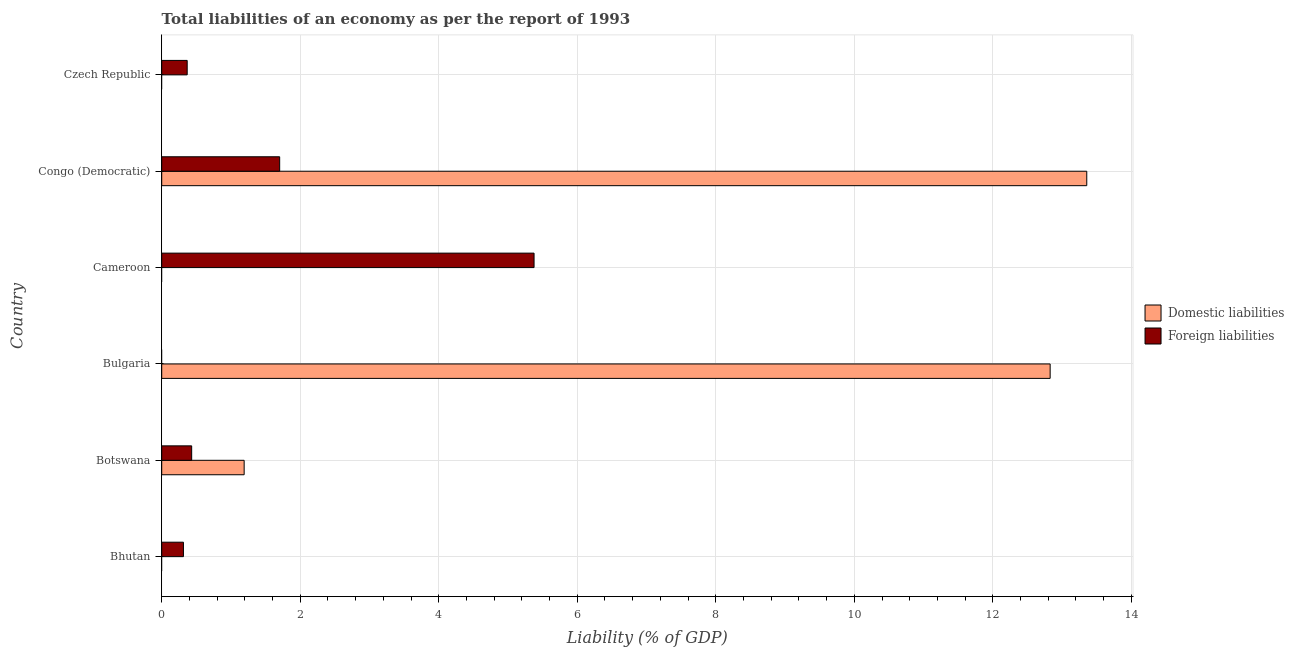How many different coloured bars are there?
Provide a succinct answer. 2. Are the number of bars on each tick of the Y-axis equal?
Provide a succinct answer. No. What is the incurrence of foreign liabilities in Botswana?
Offer a terse response. 0.43. Across all countries, what is the maximum incurrence of foreign liabilities?
Give a very brief answer. 5.38. Across all countries, what is the minimum incurrence of domestic liabilities?
Your answer should be very brief. 0. In which country was the incurrence of foreign liabilities maximum?
Your answer should be very brief. Cameroon. What is the total incurrence of foreign liabilities in the graph?
Keep it short and to the point. 8.19. What is the difference between the incurrence of foreign liabilities in Botswana and that in Congo (Democratic)?
Offer a very short reply. -1.27. What is the difference between the incurrence of foreign liabilities in Cameroon and the incurrence of domestic liabilities in Bhutan?
Make the answer very short. 5.38. What is the average incurrence of domestic liabilities per country?
Offer a terse response. 4.56. What is the difference between the incurrence of foreign liabilities and incurrence of domestic liabilities in Congo (Democratic)?
Your response must be concise. -11.65. What is the ratio of the incurrence of foreign liabilities in Botswana to that in Czech Republic?
Keep it short and to the point. 1.18. Is the incurrence of domestic liabilities in Botswana less than that in Bulgaria?
Provide a succinct answer. Yes. What is the difference between the highest and the second highest incurrence of foreign liabilities?
Your answer should be very brief. 3.67. What is the difference between the highest and the lowest incurrence of foreign liabilities?
Provide a short and direct response. 5.38. In how many countries, is the incurrence of domestic liabilities greater than the average incurrence of domestic liabilities taken over all countries?
Offer a terse response. 2. Is the sum of the incurrence of foreign liabilities in Bhutan and Cameroon greater than the maximum incurrence of domestic liabilities across all countries?
Make the answer very short. No. How many bars are there?
Your response must be concise. 8. Are all the bars in the graph horizontal?
Offer a very short reply. Yes. How many countries are there in the graph?
Give a very brief answer. 6. What is the difference between two consecutive major ticks on the X-axis?
Make the answer very short. 2. Does the graph contain any zero values?
Provide a succinct answer. Yes. How are the legend labels stacked?
Your response must be concise. Vertical. What is the title of the graph?
Provide a succinct answer. Total liabilities of an economy as per the report of 1993. Does "Under-5(female)" appear as one of the legend labels in the graph?
Make the answer very short. No. What is the label or title of the X-axis?
Your answer should be very brief. Liability (% of GDP). What is the label or title of the Y-axis?
Your response must be concise. Country. What is the Liability (% of GDP) in Foreign liabilities in Bhutan?
Your response must be concise. 0.31. What is the Liability (% of GDP) of Domestic liabilities in Botswana?
Offer a terse response. 1.19. What is the Liability (% of GDP) in Foreign liabilities in Botswana?
Give a very brief answer. 0.43. What is the Liability (% of GDP) in Domestic liabilities in Bulgaria?
Provide a succinct answer. 12.83. What is the Liability (% of GDP) in Foreign liabilities in Bulgaria?
Give a very brief answer. 0. What is the Liability (% of GDP) in Domestic liabilities in Cameroon?
Provide a short and direct response. 0. What is the Liability (% of GDP) of Foreign liabilities in Cameroon?
Provide a succinct answer. 5.38. What is the Liability (% of GDP) of Domestic liabilities in Congo (Democratic)?
Give a very brief answer. 13.36. What is the Liability (% of GDP) in Foreign liabilities in Congo (Democratic)?
Keep it short and to the point. 1.7. What is the Liability (% of GDP) in Domestic liabilities in Czech Republic?
Give a very brief answer. 0. What is the Liability (% of GDP) in Foreign liabilities in Czech Republic?
Provide a succinct answer. 0.37. Across all countries, what is the maximum Liability (% of GDP) of Domestic liabilities?
Your response must be concise. 13.36. Across all countries, what is the maximum Liability (% of GDP) in Foreign liabilities?
Your answer should be very brief. 5.38. What is the total Liability (% of GDP) in Domestic liabilities in the graph?
Provide a succinct answer. 27.37. What is the total Liability (% of GDP) in Foreign liabilities in the graph?
Make the answer very short. 8.19. What is the difference between the Liability (% of GDP) of Foreign liabilities in Bhutan and that in Botswana?
Your answer should be very brief. -0.12. What is the difference between the Liability (% of GDP) of Foreign liabilities in Bhutan and that in Cameroon?
Provide a succinct answer. -5.06. What is the difference between the Liability (% of GDP) in Foreign liabilities in Bhutan and that in Congo (Democratic)?
Provide a succinct answer. -1.39. What is the difference between the Liability (% of GDP) of Foreign liabilities in Bhutan and that in Czech Republic?
Keep it short and to the point. -0.05. What is the difference between the Liability (% of GDP) in Domestic liabilities in Botswana and that in Bulgaria?
Ensure brevity in your answer.  -11.64. What is the difference between the Liability (% of GDP) of Foreign liabilities in Botswana and that in Cameroon?
Your answer should be very brief. -4.94. What is the difference between the Liability (% of GDP) in Domestic liabilities in Botswana and that in Congo (Democratic)?
Offer a very short reply. -12.17. What is the difference between the Liability (% of GDP) of Foreign liabilities in Botswana and that in Congo (Democratic)?
Your response must be concise. -1.27. What is the difference between the Liability (% of GDP) of Foreign liabilities in Botswana and that in Czech Republic?
Your response must be concise. 0.06. What is the difference between the Liability (% of GDP) in Domestic liabilities in Bulgaria and that in Congo (Democratic)?
Give a very brief answer. -0.53. What is the difference between the Liability (% of GDP) in Foreign liabilities in Cameroon and that in Congo (Democratic)?
Offer a very short reply. 3.67. What is the difference between the Liability (% of GDP) of Foreign liabilities in Cameroon and that in Czech Republic?
Give a very brief answer. 5.01. What is the difference between the Liability (% of GDP) of Foreign liabilities in Congo (Democratic) and that in Czech Republic?
Offer a very short reply. 1.34. What is the difference between the Liability (% of GDP) in Domestic liabilities in Botswana and the Liability (% of GDP) in Foreign liabilities in Cameroon?
Give a very brief answer. -4.19. What is the difference between the Liability (% of GDP) in Domestic liabilities in Botswana and the Liability (% of GDP) in Foreign liabilities in Congo (Democratic)?
Offer a terse response. -0.51. What is the difference between the Liability (% of GDP) in Domestic liabilities in Botswana and the Liability (% of GDP) in Foreign liabilities in Czech Republic?
Provide a succinct answer. 0.82. What is the difference between the Liability (% of GDP) in Domestic liabilities in Bulgaria and the Liability (% of GDP) in Foreign liabilities in Cameroon?
Offer a terse response. 7.45. What is the difference between the Liability (% of GDP) of Domestic liabilities in Bulgaria and the Liability (% of GDP) of Foreign liabilities in Congo (Democratic)?
Ensure brevity in your answer.  11.12. What is the difference between the Liability (% of GDP) in Domestic liabilities in Bulgaria and the Liability (% of GDP) in Foreign liabilities in Czech Republic?
Offer a terse response. 12.46. What is the difference between the Liability (% of GDP) in Domestic liabilities in Congo (Democratic) and the Liability (% of GDP) in Foreign liabilities in Czech Republic?
Give a very brief answer. 12.99. What is the average Liability (% of GDP) of Domestic liabilities per country?
Keep it short and to the point. 4.56. What is the average Liability (% of GDP) in Foreign liabilities per country?
Ensure brevity in your answer.  1.37. What is the difference between the Liability (% of GDP) in Domestic liabilities and Liability (% of GDP) in Foreign liabilities in Botswana?
Your answer should be very brief. 0.76. What is the difference between the Liability (% of GDP) in Domestic liabilities and Liability (% of GDP) in Foreign liabilities in Congo (Democratic)?
Provide a succinct answer. 11.65. What is the ratio of the Liability (% of GDP) in Foreign liabilities in Bhutan to that in Botswana?
Your answer should be very brief. 0.73. What is the ratio of the Liability (% of GDP) in Foreign liabilities in Bhutan to that in Cameroon?
Your response must be concise. 0.06. What is the ratio of the Liability (% of GDP) of Foreign liabilities in Bhutan to that in Congo (Democratic)?
Your answer should be compact. 0.18. What is the ratio of the Liability (% of GDP) in Foreign liabilities in Bhutan to that in Czech Republic?
Your answer should be very brief. 0.85. What is the ratio of the Liability (% of GDP) of Domestic liabilities in Botswana to that in Bulgaria?
Your answer should be compact. 0.09. What is the ratio of the Liability (% of GDP) of Foreign liabilities in Botswana to that in Cameroon?
Keep it short and to the point. 0.08. What is the ratio of the Liability (% of GDP) of Domestic liabilities in Botswana to that in Congo (Democratic)?
Ensure brevity in your answer.  0.09. What is the ratio of the Liability (% of GDP) in Foreign liabilities in Botswana to that in Congo (Democratic)?
Offer a very short reply. 0.25. What is the ratio of the Liability (% of GDP) in Foreign liabilities in Botswana to that in Czech Republic?
Offer a very short reply. 1.18. What is the ratio of the Liability (% of GDP) in Domestic liabilities in Bulgaria to that in Congo (Democratic)?
Give a very brief answer. 0.96. What is the ratio of the Liability (% of GDP) of Foreign liabilities in Cameroon to that in Congo (Democratic)?
Give a very brief answer. 3.16. What is the ratio of the Liability (% of GDP) in Foreign liabilities in Cameroon to that in Czech Republic?
Your answer should be very brief. 14.62. What is the ratio of the Liability (% of GDP) in Foreign liabilities in Congo (Democratic) to that in Czech Republic?
Your answer should be very brief. 4.63. What is the difference between the highest and the second highest Liability (% of GDP) of Domestic liabilities?
Your response must be concise. 0.53. What is the difference between the highest and the second highest Liability (% of GDP) of Foreign liabilities?
Make the answer very short. 3.67. What is the difference between the highest and the lowest Liability (% of GDP) in Domestic liabilities?
Offer a very short reply. 13.36. What is the difference between the highest and the lowest Liability (% of GDP) in Foreign liabilities?
Provide a short and direct response. 5.38. 